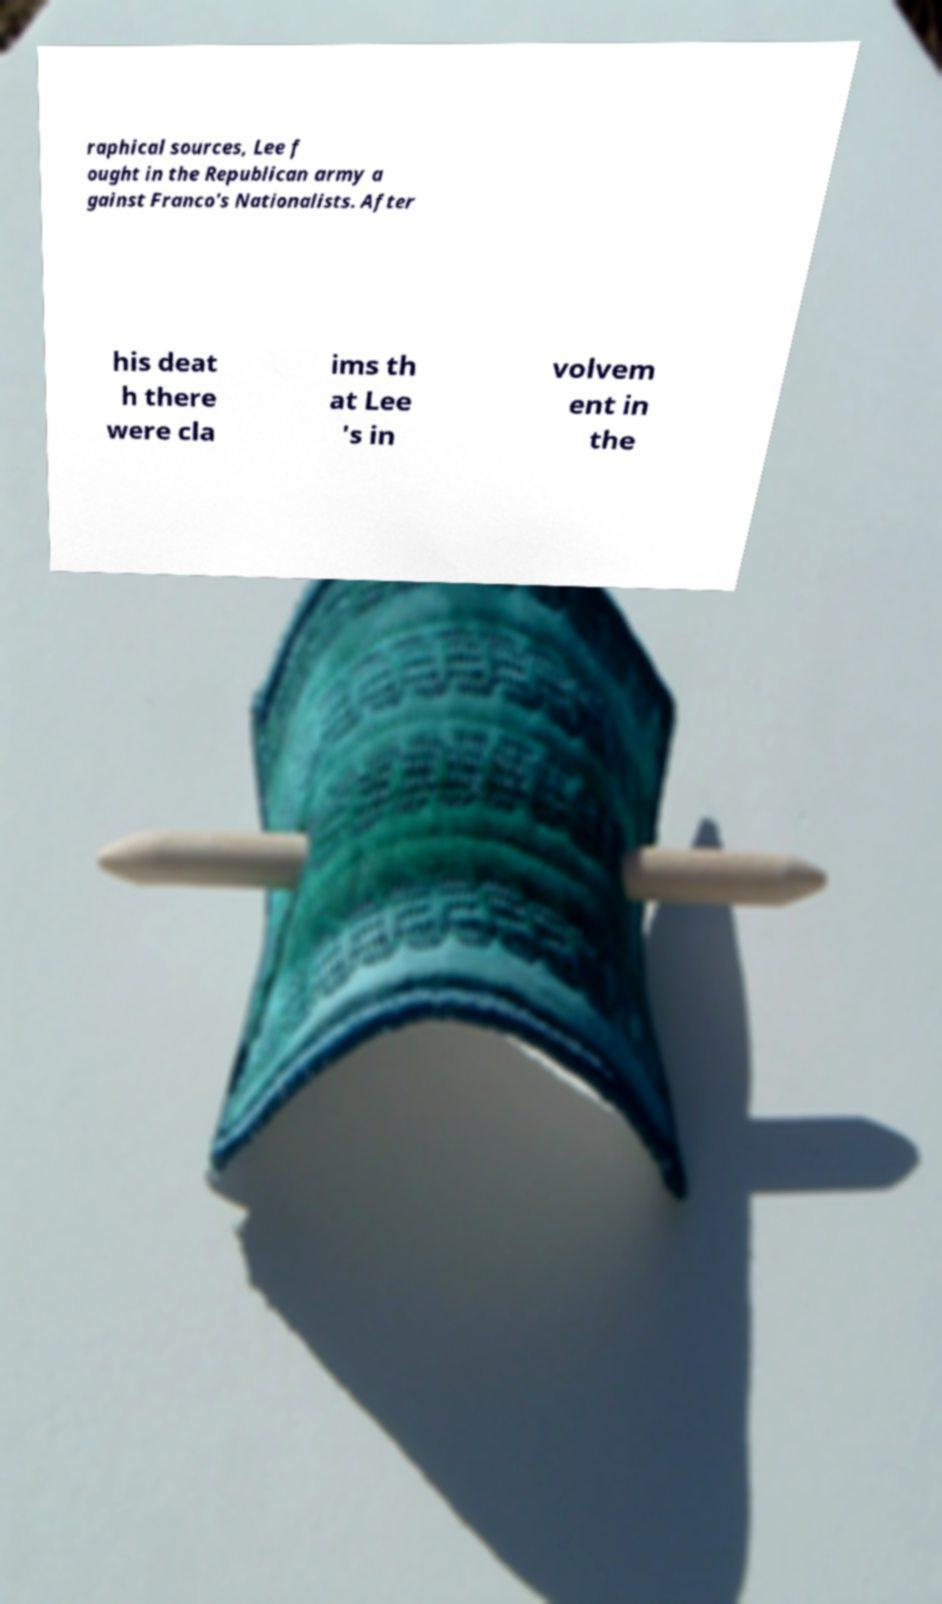What messages or text are displayed in this image? I need them in a readable, typed format. raphical sources, Lee f ought in the Republican army a gainst Franco's Nationalists. After his deat h there were cla ims th at Lee 's in volvem ent in the 